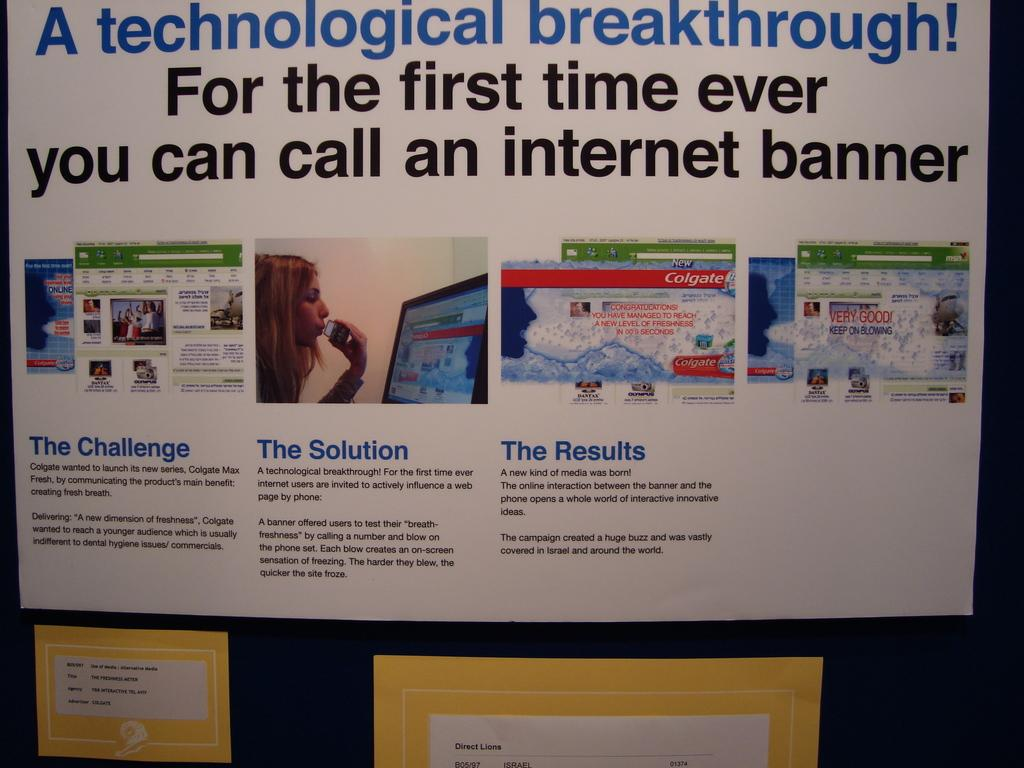<image>
Give a short and clear explanation of the subsequent image. a posterboard that has a technical breakthrough on it 